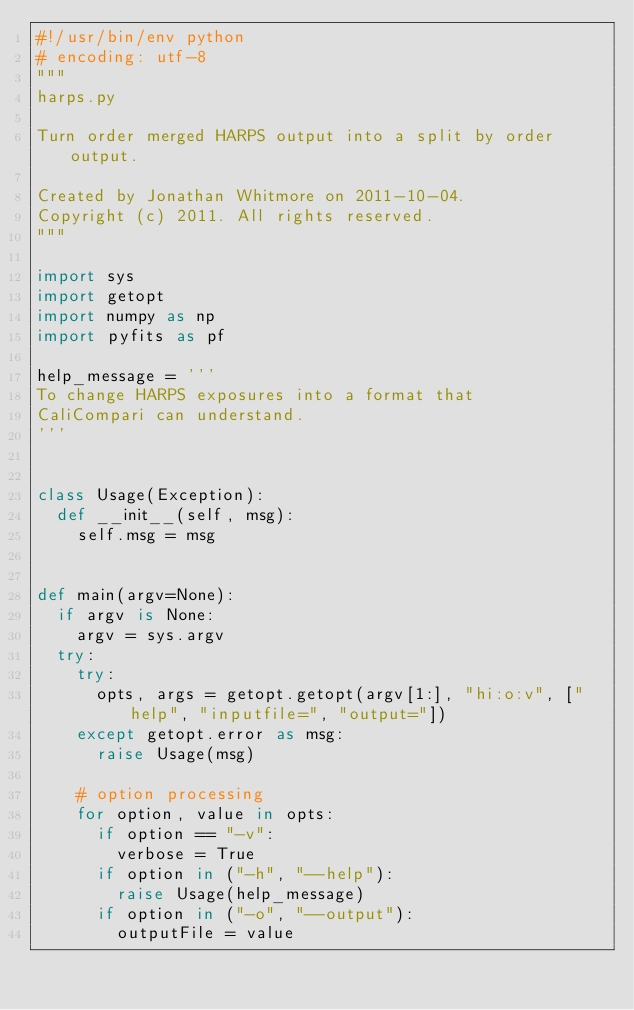<code> <loc_0><loc_0><loc_500><loc_500><_Python_>#!/usr/bin/env python
# encoding: utf-8
"""
harps.py

Turn order merged HARPS output into a split by order output.

Created by Jonathan Whitmore on 2011-10-04.
Copyright (c) 2011. All rights reserved.
"""

import sys
import getopt
import numpy as np
import pyfits as pf

help_message = '''
To change HARPS exposures into a format that 
CaliCompari can understand.
'''


class Usage(Exception):
  def __init__(self, msg):
    self.msg = msg


def main(argv=None):
  if argv is None:
    argv = sys.argv
  try:
    try:
      opts, args = getopt.getopt(argv[1:], "hi:o:v", ["help", "inputfile=", "output="])
    except getopt.error as msg:
      raise Usage(msg)
    
    # option processing
    for option, value in opts:
      if option == "-v":
        verbose = True
      if option in ("-h", "--help"):
        raise Usage(help_message)
      if option in ("-o", "--output"):
        outputFile = value</code> 